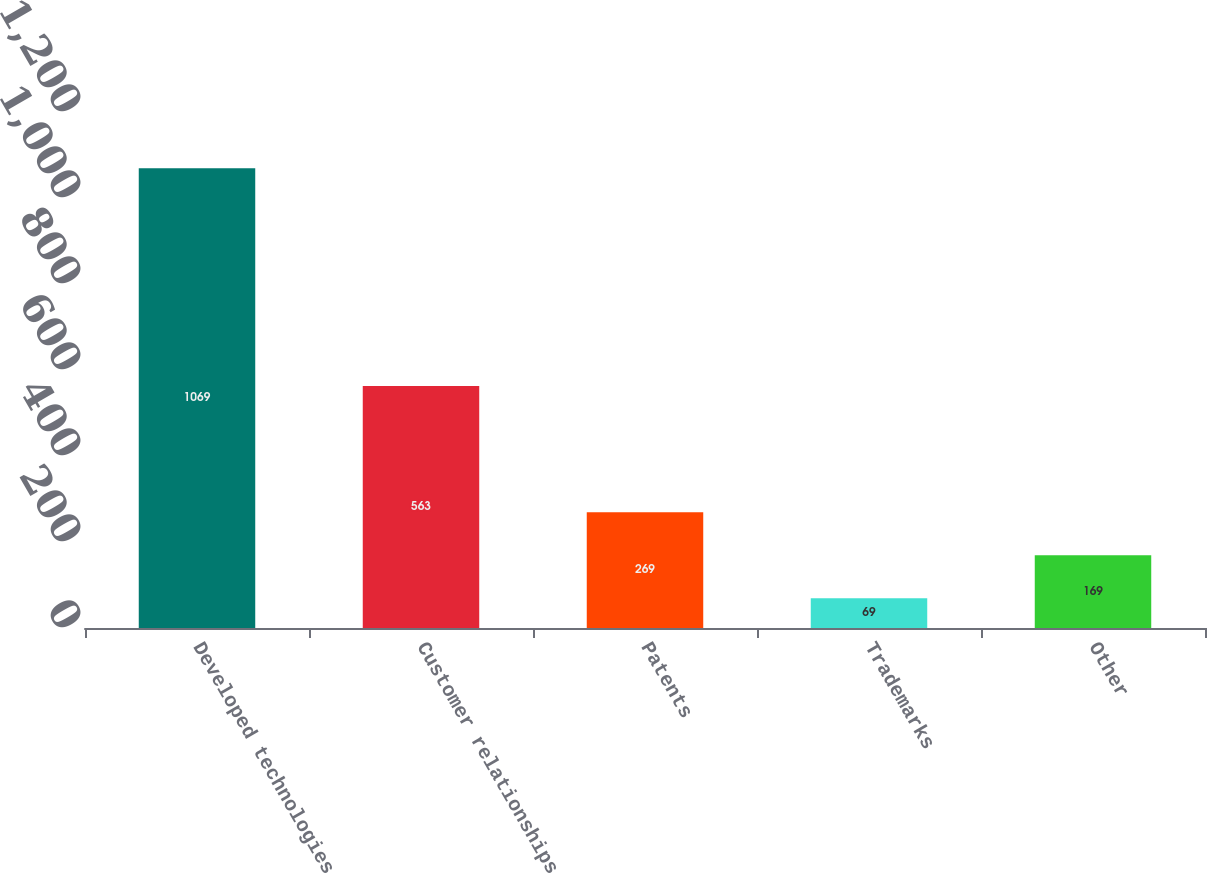Convert chart to OTSL. <chart><loc_0><loc_0><loc_500><loc_500><bar_chart><fcel>Developed technologies<fcel>Customer relationships<fcel>Patents<fcel>Trademarks<fcel>Other<nl><fcel>1069<fcel>563<fcel>269<fcel>69<fcel>169<nl></chart> 